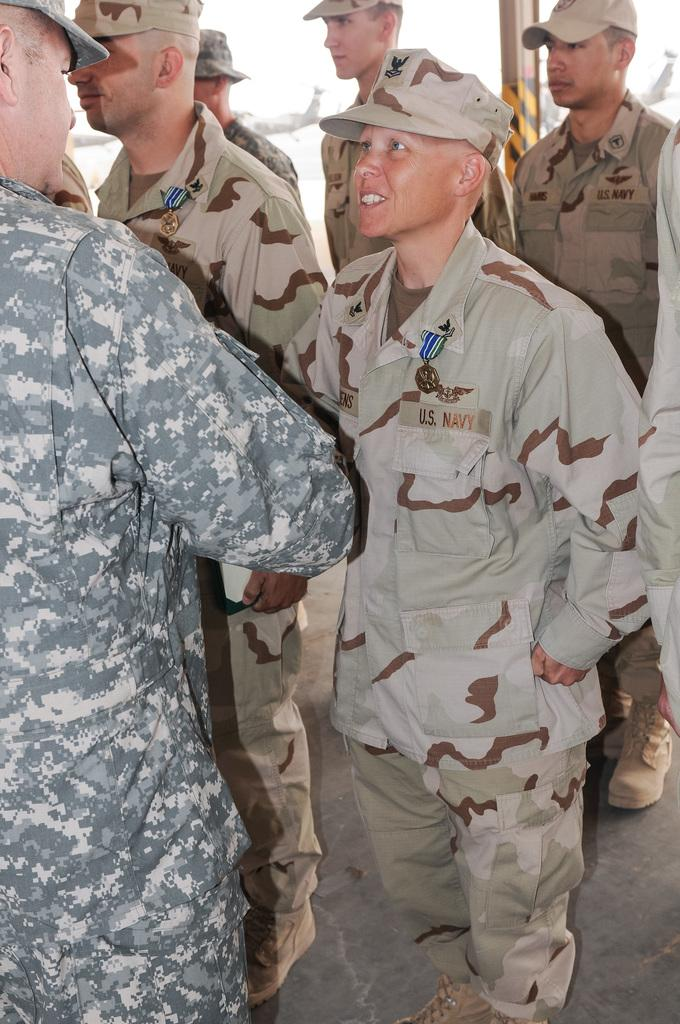How many people are in the image? There are people in the image, but the exact number is not specified. What is the surface beneath the people in the image? The people are standing on a floor. What grade did the person in the image receive for their performance? There is no indication of a performance or a grade in the image. 